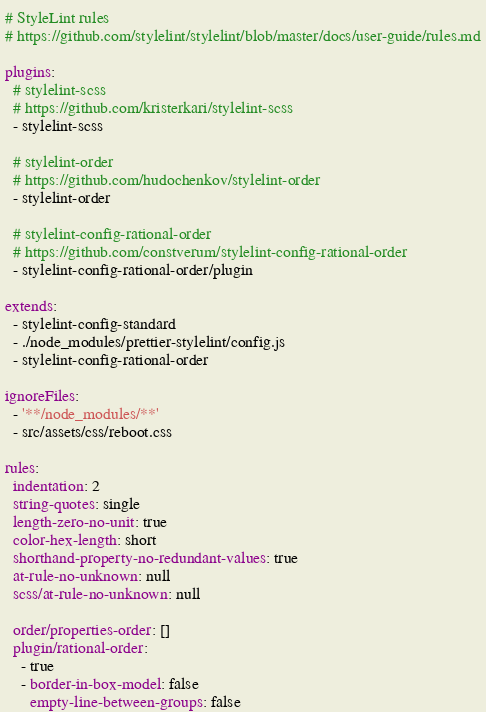Convert code to text. <code><loc_0><loc_0><loc_500><loc_500><_YAML_># StyleLint rules
# https://github.com/stylelint/stylelint/blob/master/docs/user-guide/rules.md

plugins:
  # stylelint-scss
  # https://github.com/kristerkari/stylelint-scss
  - stylelint-scss

  # stylelint-order
  # https://github.com/hudochenkov/stylelint-order
  - stylelint-order

  # stylelint-config-rational-order
  # https://github.com/constverum/stylelint-config-rational-order
  - stylelint-config-rational-order/plugin

extends:
  - stylelint-config-standard
  - ./node_modules/prettier-stylelint/config.js
  - stylelint-config-rational-order

ignoreFiles:
  - '**/node_modules/**'
  - src/assets/css/reboot.css

rules:
  indentation: 2
  string-quotes: single
  length-zero-no-unit: true
  color-hex-length: short
  shorthand-property-no-redundant-values: true
  at-rule-no-unknown: null
  scss/at-rule-no-unknown: null

  order/properties-order: []
  plugin/rational-order:
    - true
    - border-in-box-model: false
      empty-line-between-groups: false
</code> 